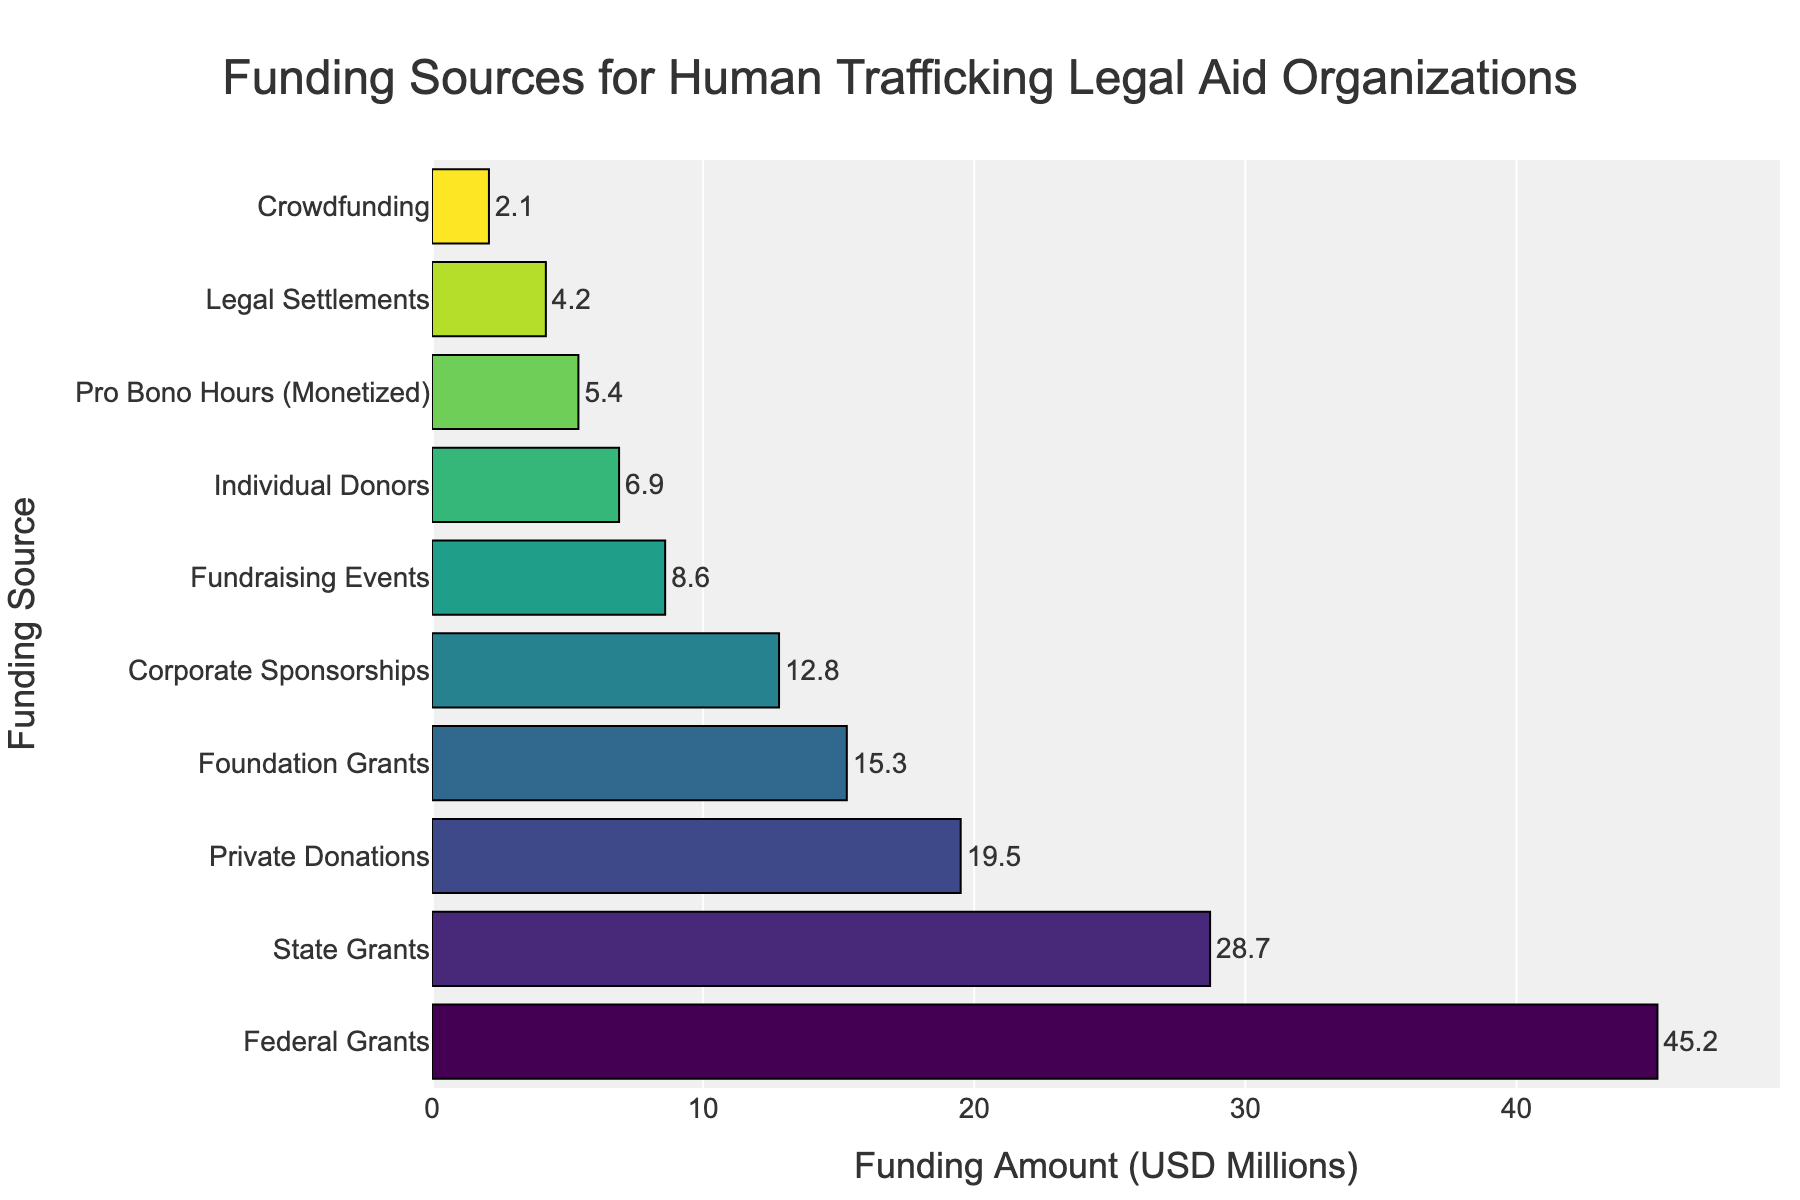What is the combined funding amount from Federal Grants and State Grants? To find the combined funding amount from Federal Grants and State Grants, add the funding amounts together: 45.2 + 28.7 = 73.9
Answer: 73.9 Which funding source has the highest funding amount? The bar representing Federal Grants is the longest, indicating it has the highest funding amount of 45.2 million USD.
Answer: Federal Grants How does the funding amount from Crowdfunding compare to Private Donations? The Crowdfunding funding amount is 2.1 million USD, while Private Donations is 19.5 million USD. Since 2.1 is much less than 19.5, Crowdfunding is significantly smaller than Private Donations.
Answer: Crowdfunding is smaller Which funding source contributes the least, and what is its funding amount? The shortest bar represents Crowdfunding, which indicates it has the least funding amount of 2.1 million USD.
Answer: Crowdfunding, 2.1 What is the difference in funding amount between Fundraising Events and Corporate Sponsorships? Subtract the funding amount of Fundraising Events from Corporate Sponsorships: 12.8 - 8.6 = 4.2 million USD
Answer: 4.2 What are the funding amounts for Legal Settlements and Pro Bono Hours combined? Add the funding amounts for Legal Settlements and Pro Bono Hours: 4.2 + 5.4 = 9.6 million USD
Answer: 9.6 Is the amount from Individual Donors more than Pro Bono Hours? If so, by how much? Individual Donors have a funding amount of 6.9 million USD, while Pro Bono Hours have 5.4 million USD. Subtract Pro Bono Hours from Individual Donors: 6.9 - 5.4 = 1.5 million USD
Answer: Yes, by 1.5 million USD Among Corporate Sponsorships, Fundraising Events, and Individual Donors, which has the highest funding amount, and what are the respective amounts? Corporate Sponsorships have 12.8 million USD, Fundraising Events have 8.6 million USD, and Individual Donors have 6.9 million USD. Corporate Sponsorships have the highest amount.
Answer: Corporate Sponsorships: 12.8, Fundraising Events: 8.6, Individual Donors: 6.9 How much more funding does Federal Grants receive than Foundation Grants? Subtract the funding amount of Foundation Grants from Federal Grants: 45.2 - 15.3 = 29.9 million USD
Answer: 29.9 